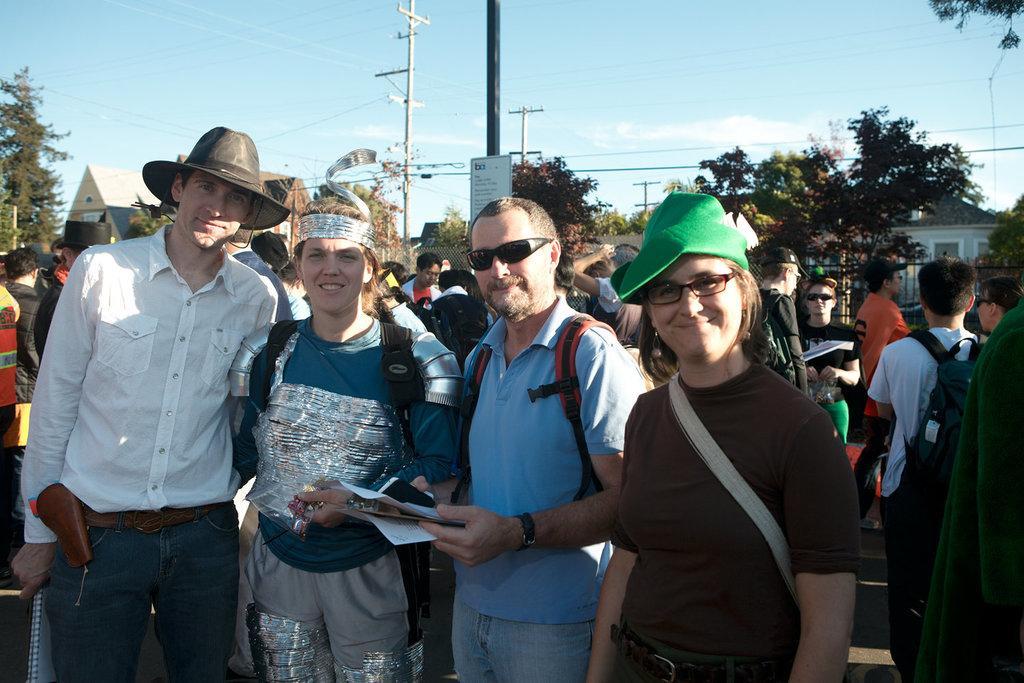Describe this image in one or two sentences. This image is clicked on the road. There are many people standing. In the foreground there are four people standing and they are smiling. Behind them there is a pole. There is a board on the pole. In the background there are trees, houses and electric poles. At the top there is the sky. 